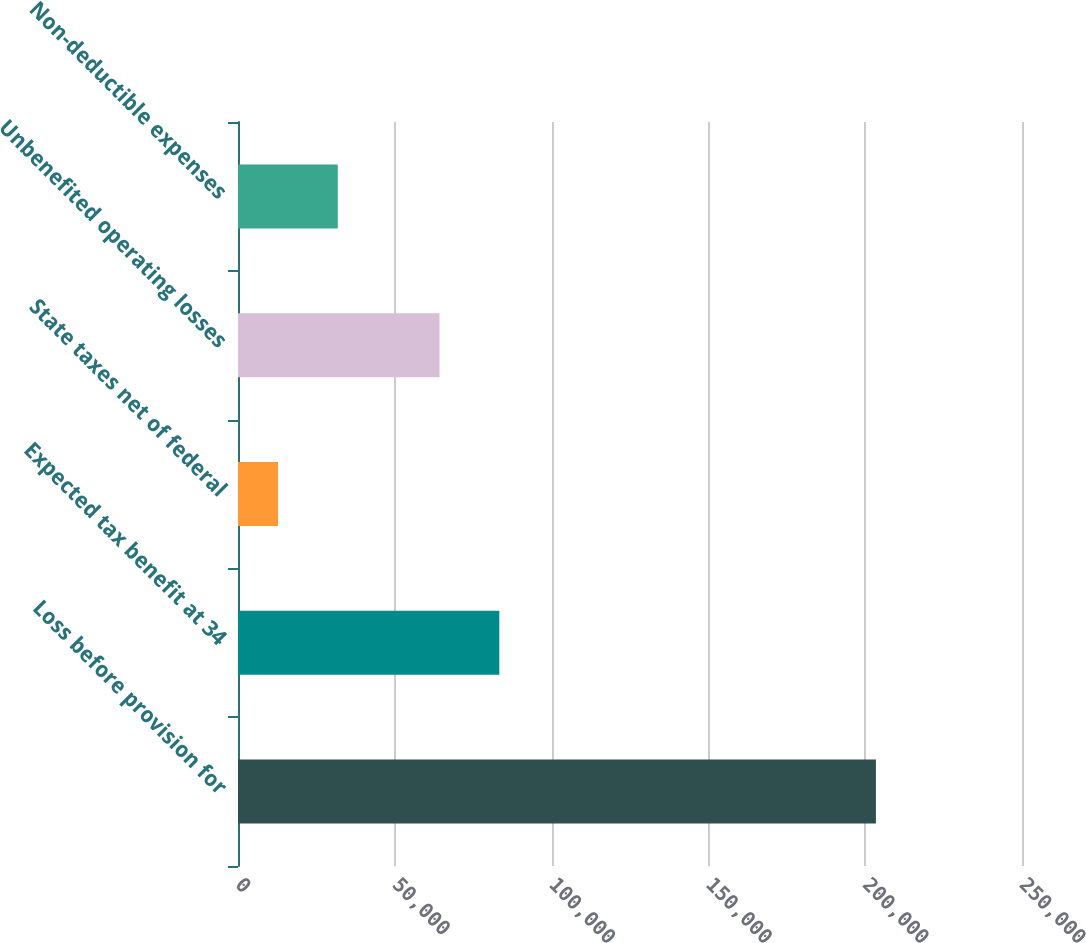Convert chart to OTSL. <chart><loc_0><loc_0><loc_500><loc_500><bar_chart><fcel>Loss before provision for<fcel>Expected tax benefit at 34<fcel>State taxes net of federal<fcel>Unbenefited operating losses<fcel>Non-deductible expenses<nl><fcel>203417<fcel>83328.3<fcel>12754<fcel>64262<fcel>31820.3<nl></chart> 